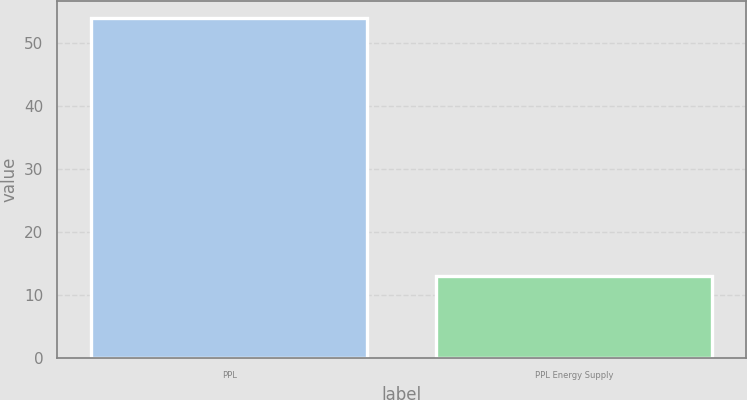Convert chart. <chart><loc_0><loc_0><loc_500><loc_500><bar_chart><fcel>PPL<fcel>PPL Energy Supply<nl><fcel>54<fcel>13<nl></chart> 